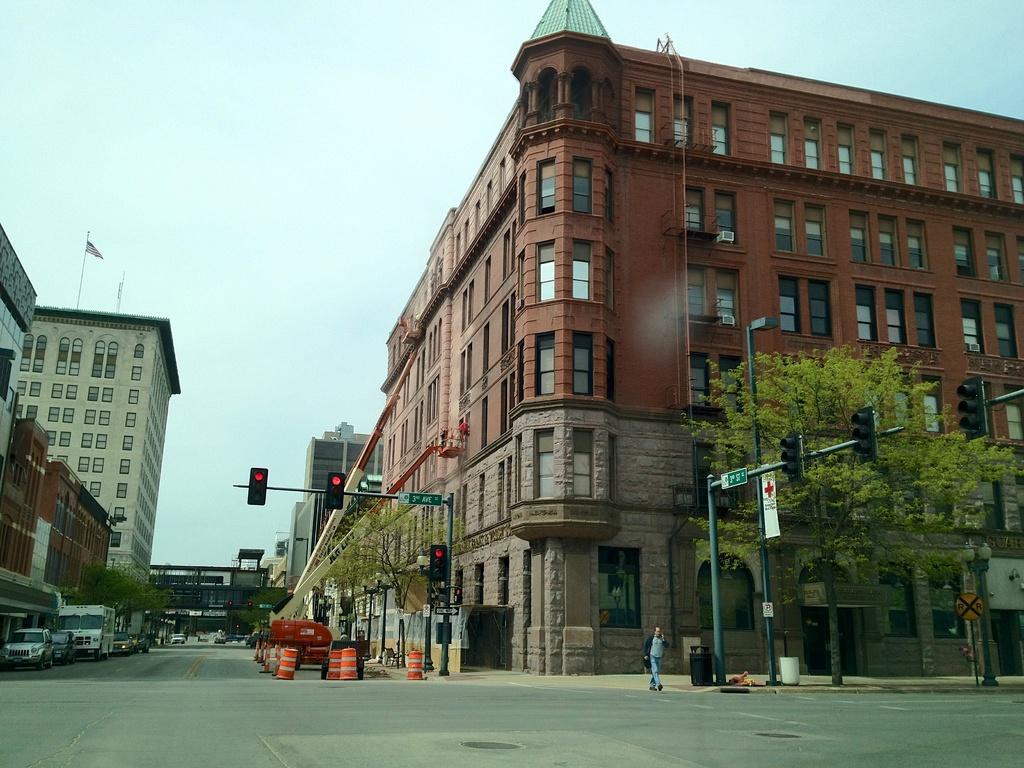Could you give a brief overview of what you see in this image? In this image we can see buildings, person, vehicles, sign boards, light poles, signal lights, trees and objects. Above this building there is a flag. This is sky. To these buildings there are windows. Beside these poles there are bins. 